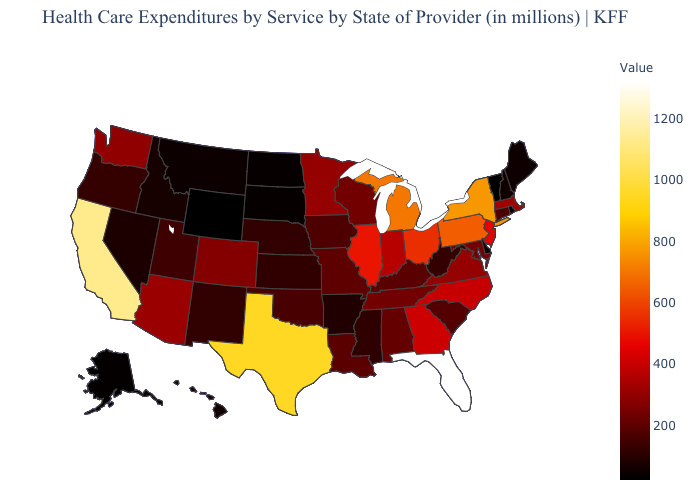Which states hav the highest value in the South?
Give a very brief answer. Florida. Which states hav the highest value in the South?
Give a very brief answer. Florida. Does the map have missing data?
Give a very brief answer. No. Does the map have missing data?
Short answer required. No. Among the states that border Arkansas , does Mississippi have the lowest value?
Short answer required. Yes. Does the map have missing data?
Quick response, please. No. 